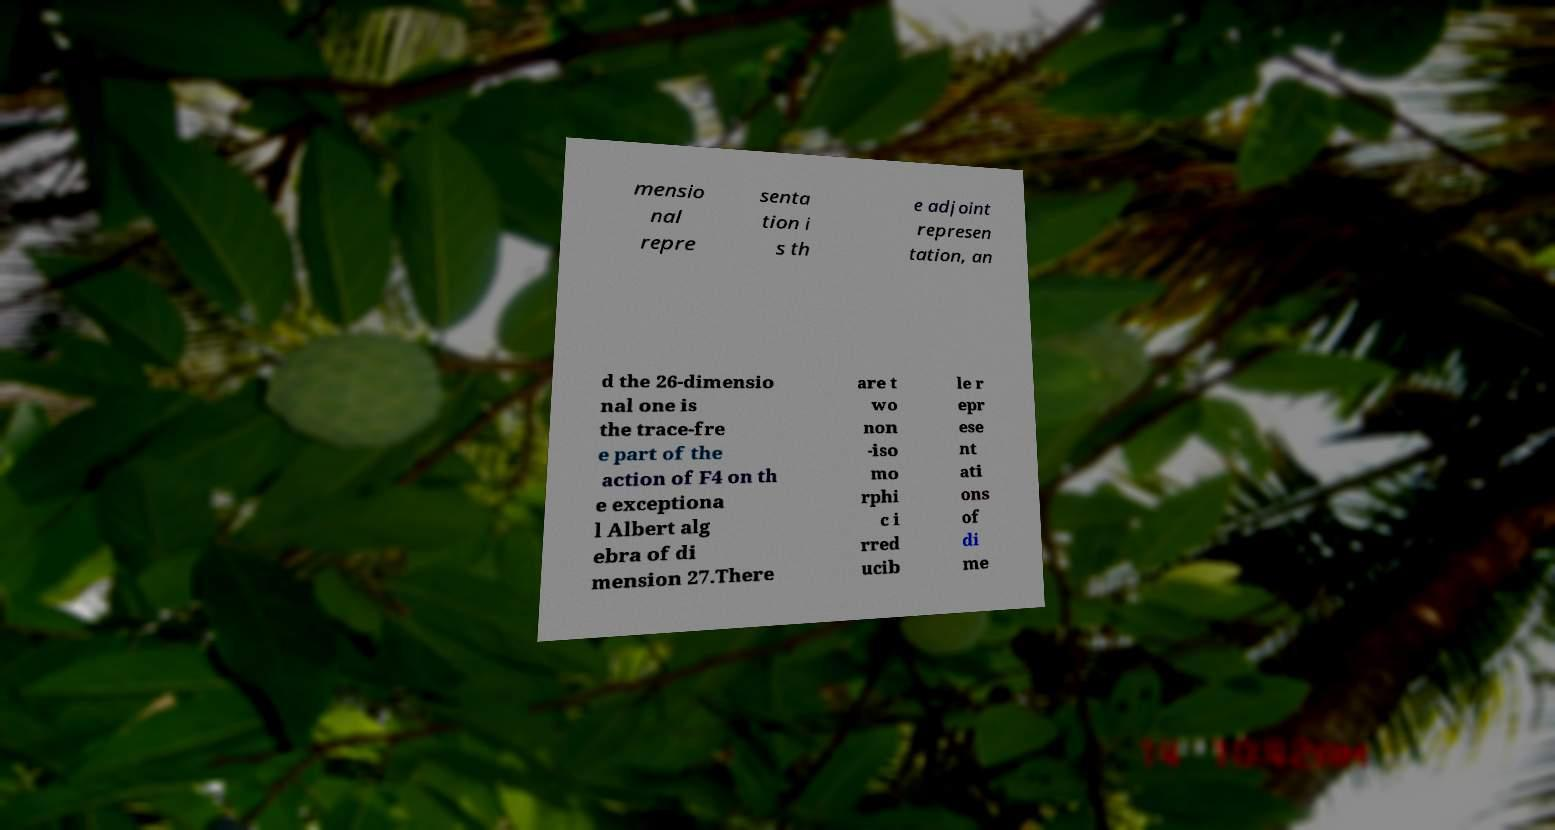Can you accurately transcribe the text from the provided image for me? mensio nal repre senta tion i s th e adjoint represen tation, an d the 26-dimensio nal one is the trace-fre e part of the action of F4 on th e exceptiona l Albert alg ebra of di mension 27.There are t wo non -iso mo rphi c i rred ucib le r epr ese nt ati ons of di me 